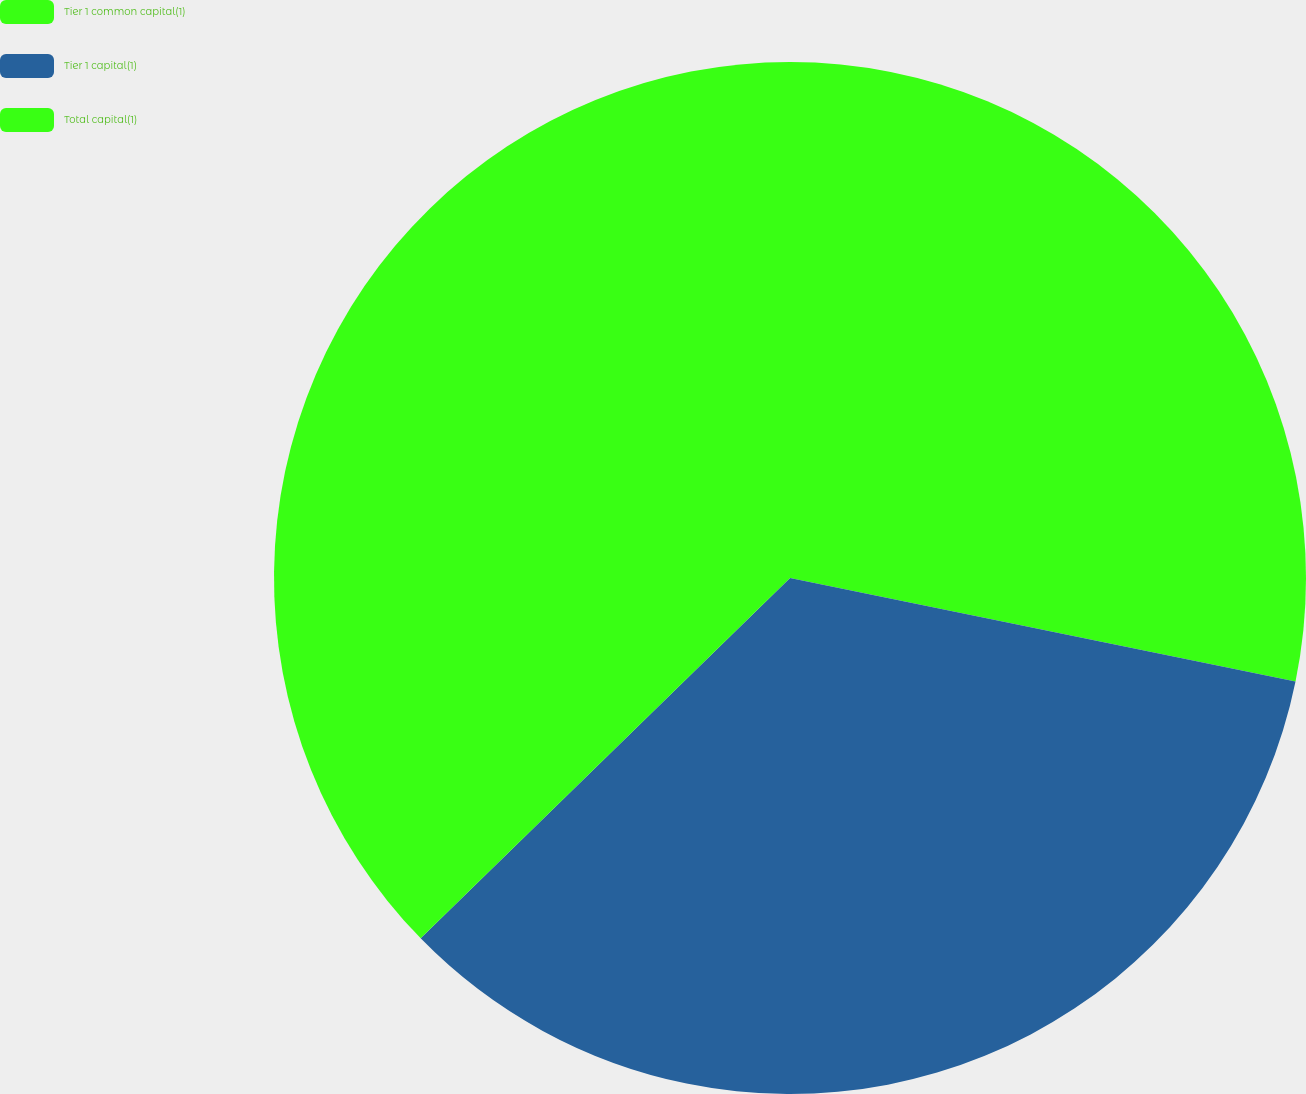<chart> <loc_0><loc_0><loc_500><loc_500><pie_chart><fcel>Tier 1 common capital(1)<fcel>Tier 1 capital(1)<fcel>Total capital(1)<nl><fcel>28.21%<fcel>34.48%<fcel>37.3%<nl></chart> 